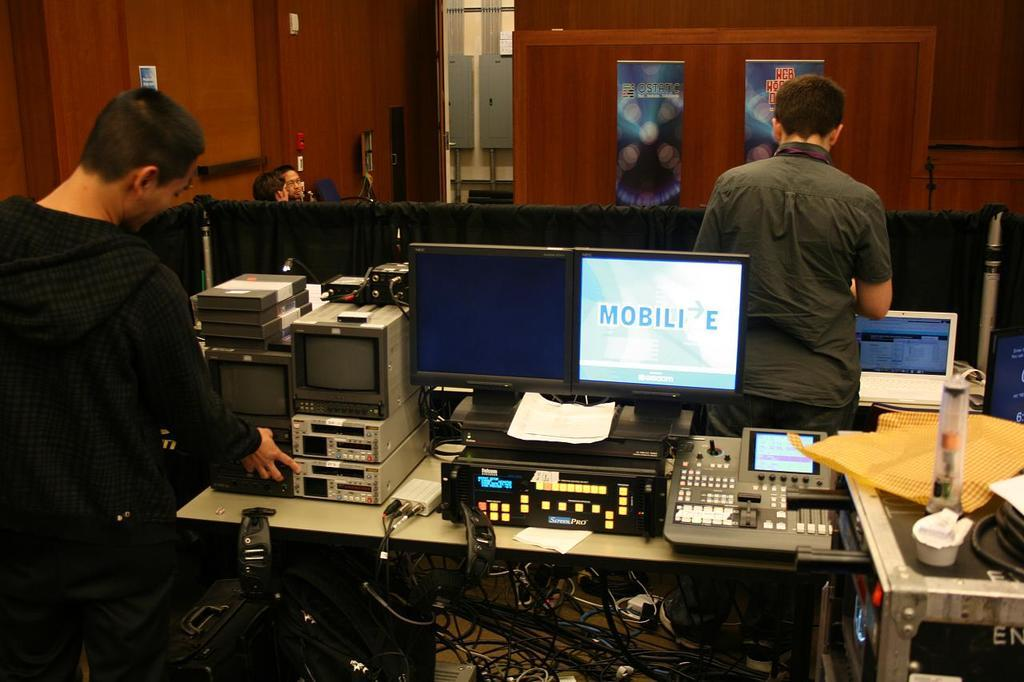<image>
Describe the image concisely. A computer monitor says MOBILI E on it with an arrow pointing to the right. 